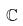Convert formula to latex. <formula><loc_0><loc_0><loc_500><loc_500>\mathbb { C }</formula> 